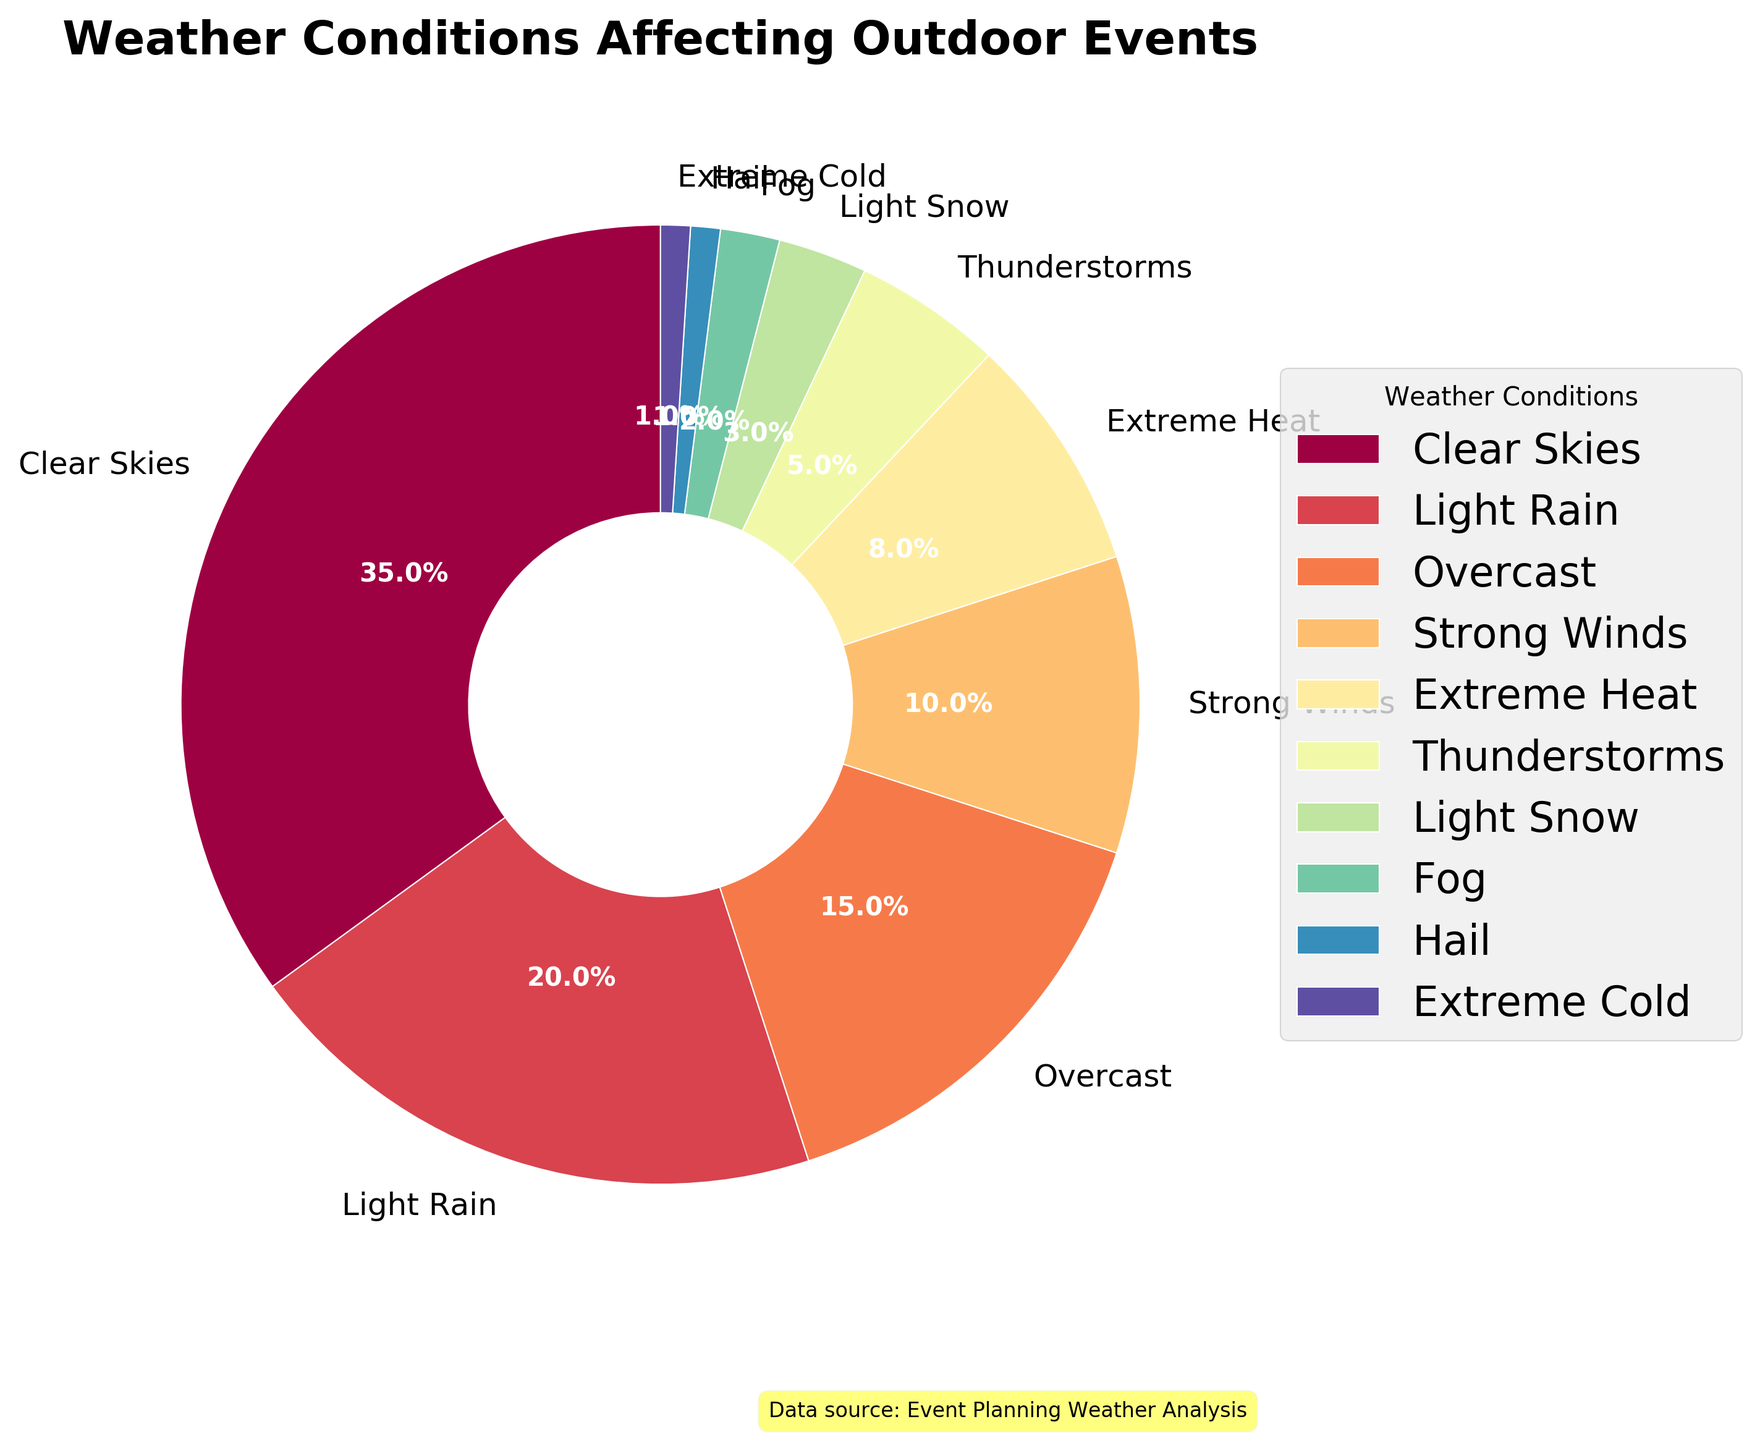What's the percentage of Clear Skies and Overcast combined? Clear Skies is 35%, Overcast is 15%. To find the combined percentage, add these two values: 35% + 15% = 50%.
Answer: 50% Which weather condition is the least frequent and what is its percentage? By observing the pie chart, Hail and Extreme Cold both have the smallest slices, each with a percentage of 1%.
Answer: Hail or Extreme Cold, 1% Are there more Clear Skies or Thunderstorms? By comparing the sizes of slices, Clear Skies has 35% while Thunderstorms have 5%. Therefore, Clear Skies is more frequent than Thunderstorms.
Answer: Clear Skies How much larger is the percentage of Light Rain compared to Light Snow? Light Rain is 20% and Light Snow is 3%. The difference is 20% - 3% = 17%.
Answer: 17% Which three weather conditions are the most common for affecting outdoor events? Clear Skies (35%), Light Rain (20%), and Overcast (15%) have the largest slices on the chart, making them the most common.
Answer: Clear Skies, Light Rain, Overcast What is the total percentage of conditions that include precipitation (Light Rain, Thunderstorms, Light Snow, Hail)? Add the percentages of Light Rain (20%), Thunderstorms (5%), Light Snow (3%), and Hail (1%): 20% + 5% + 3% + 1% = 29%.
Answer: 29% If you combine the percentages of Extreme Heat and Extreme Cold, how does the result compare to Strong Winds? Extreme Heat is 8% and Extreme Cold is 1%, their combined percentage is 8% + 1% = 9%. Strong Winds is 10%. Therefore, 9% is less than 10%.
Answer: Less than What percentage of events are affected by visibility issues (Fog)? From the pie chart, the slice for Fog has a percentage of 2%.
Answer: 2% How do the percentages of Strong Winds and Extreme Heat compare? Strong Winds is 10% and Extreme Heat is 8%. Strong Winds is thus 2% more than Extreme Heat.
Answer: Strong Winds What is the difference in percentage between the most and least frequent weather conditions? The most frequent condition is Clear Skies (35%), and the least frequent are Hail and Extreme Cold (each 1%). The difference is 35% - 1% = 34%.
Answer: 34% 